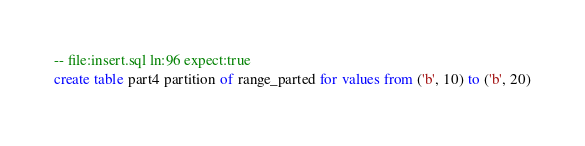Convert code to text. <code><loc_0><loc_0><loc_500><loc_500><_SQL_>-- file:insert.sql ln:96 expect:true
create table part4 partition of range_parted for values from ('b', 10) to ('b', 20)
</code> 